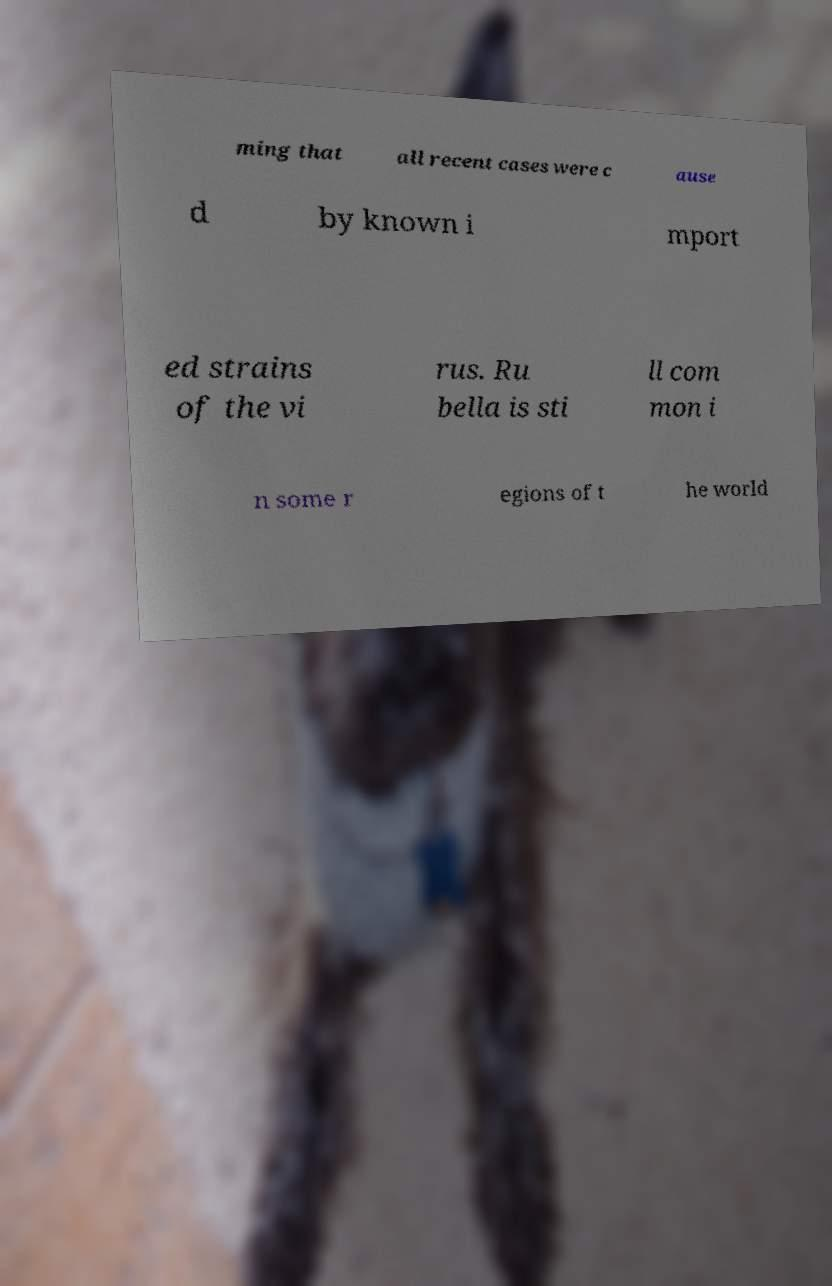Could you extract and type out the text from this image? ming that all recent cases were c ause d by known i mport ed strains of the vi rus. Ru bella is sti ll com mon i n some r egions of t he world 